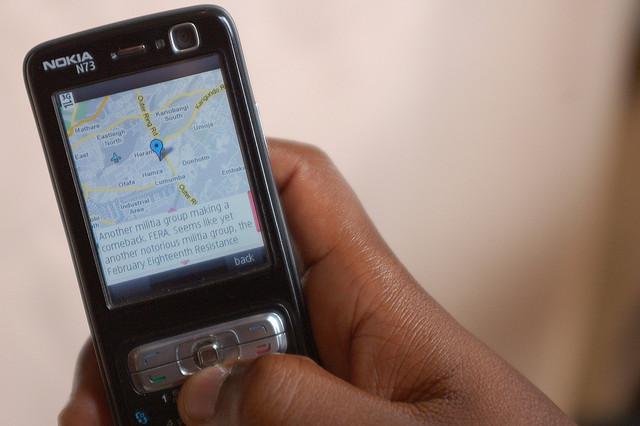What brand is the phone?
Give a very brief answer. Nokia. Is the phone working?
Give a very brief answer. Yes. Is this held by a man?
Answer briefly. Yes. Is there a map on the phone?
Give a very brief answer. Yes. Which thumb is on the button?
Be succinct. Right. What color is the persons hand holding the phone?
Concise answer only. Brown. What model of Nokia is this?
Keep it brief. N73. Is this a new model of NOKIA brand?
Short answer required. No. What is the phone for?
Be succinct. Maps. Which type of font is this?
Give a very brief answer. Regular. 